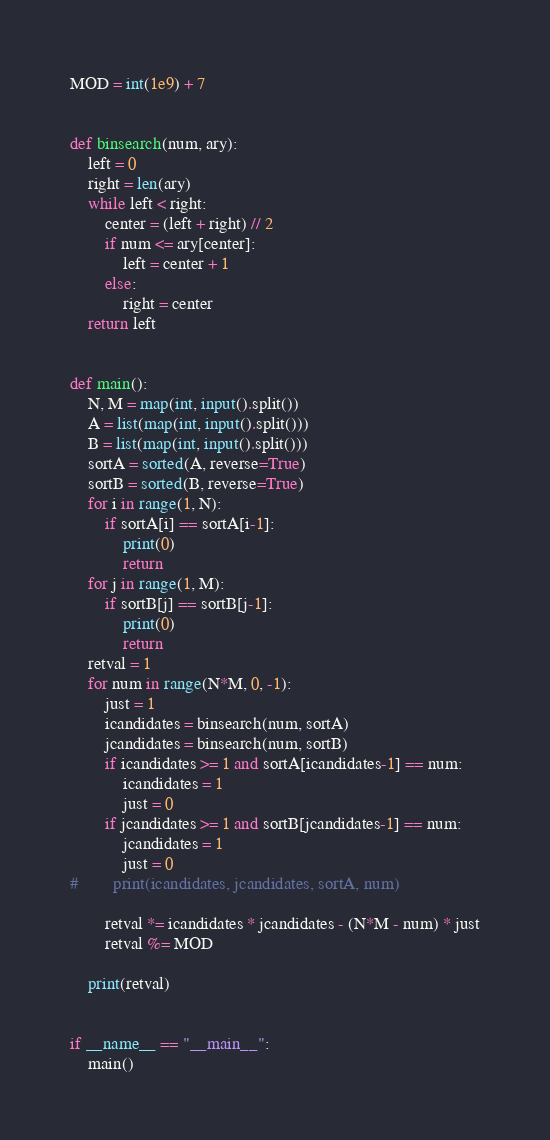<code> <loc_0><loc_0><loc_500><loc_500><_Python_>MOD = int(1e9) + 7


def binsearch(num, ary):
    left = 0
    right = len(ary)
    while left < right:
        center = (left + right) // 2
        if num <= ary[center]:
            left = center + 1
        else:
            right = center
    return left


def main():
    N, M = map(int, input().split())
    A = list(map(int, input().split()))
    B = list(map(int, input().split()))
    sortA = sorted(A, reverse=True)
    sortB = sorted(B, reverse=True)
    for i in range(1, N):
        if sortA[i] == sortA[i-1]:
            print(0)
            return
    for j in range(1, M):
        if sortB[j] == sortB[j-1]:
            print(0)
            return
    retval = 1
    for num in range(N*M, 0, -1):
        just = 1
        icandidates = binsearch(num, sortA)
        jcandidates = binsearch(num, sortB)
        if icandidates >= 1 and sortA[icandidates-1] == num:
            icandidates = 1
            just = 0
        if jcandidates >= 1 and sortB[jcandidates-1] == num:
            jcandidates = 1
            just = 0
#        print(icandidates, jcandidates, sortA, num)

        retval *= icandidates * jcandidates - (N*M - num) * just
        retval %= MOD

    print(retval)


if __name__ == "__main__":
    main()
</code> 